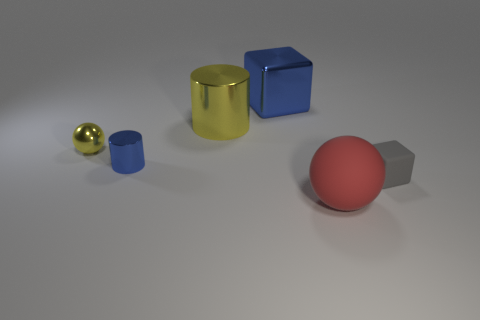Add 2 big cylinders. How many objects exist? 8 Subtract all cubes. How many objects are left? 4 Add 5 cyan cylinders. How many cyan cylinders exist? 5 Subtract 0 green blocks. How many objects are left? 6 Subtract all large metallic blocks. Subtract all gray matte cubes. How many objects are left? 4 Add 5 tiny blue metallic objects. How many tiny blue metallic objects are left? 6 